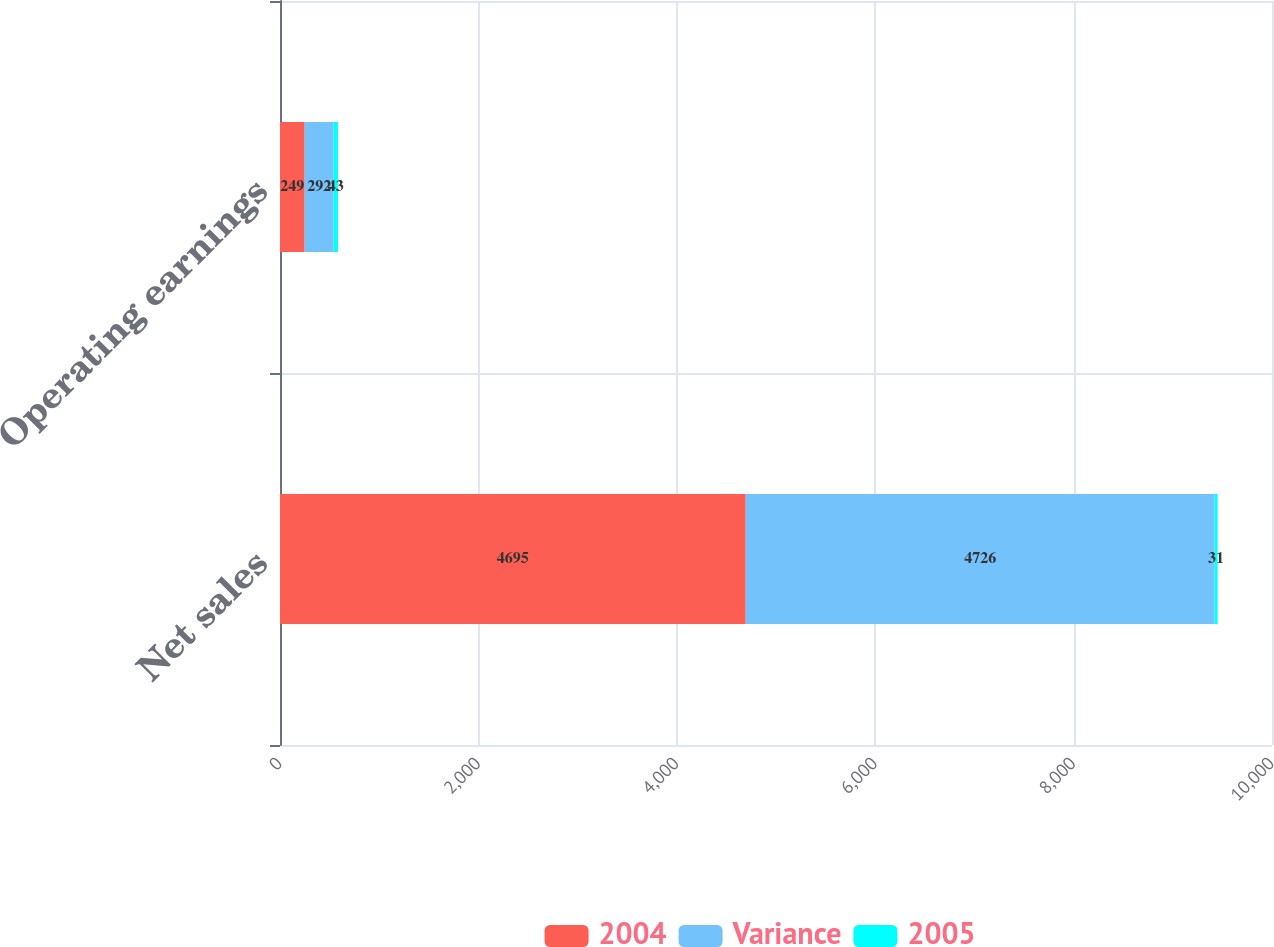Convert chart to OTSL. <chart><loc_0><loc_0><loc_500><loc_500><stacked_bar_chart><ecel><fcel>Net sales<fcel>Operating earnings<nl><fcel>2004<fcel>4695<fcel>249<nl><fcel>Variance<fcel>4726<fcel>292<nl><fcel>2005<fcel>31<fcel>43<nl></chart> 